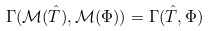<formula> <loc_0><loc_0><loc_500><loc_500>\Gamma ( \mathcal { M } ( \hat { T } ) , \mathcal { M } ( \Phi ) ) = \Gamma ( \hat { T } , \Phi )</formula> 